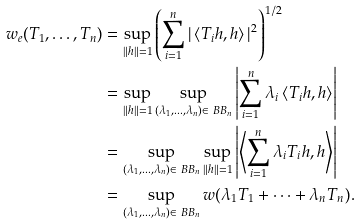Convert formula to latex. <formula><loc_0><loc_0><loc_500><loc_500>w _ { e } ( T _ { 1 } , \dots , T _ { n } ) & = \sup _ { \| h \| = 1 } \left ( \sum _ { i = 1 } ^ { n } | \left < T _ { i } h , h \right > | ^ { 2 } \right ) ^ { 1 / 2 } \\ & = \sup _ { \| h \| = 1 } \sup _ { ( \lambda _ { 1 } , \dots , \lambda _ { n } ) \in \ B B _ { n } } \left | \sum _ { i = 1 } ^ { n } \lambda _ { i } \left < T _ { i } h , h \right > \right | \\ & = \sup _ { ( \lambda _ { 1 } , \dots , \lambda _ { n } ) \in \ B B _ { n } } \sup _ { \| h \| = 1 } \left | \left < \sum _ { i = 1 } ^ { n } \lambda _ { i } T _ { i } h , h \right > \right | \\ & = \sup _ { ( \lambda _ { 1 } , \dots , \lambda _ { n } ) \in \ B B _ { n } } w ( \lambda _ { 1 } T _ { 1 } + \cdots + \lambda _ { n } T _ { n } ) .</formula> 